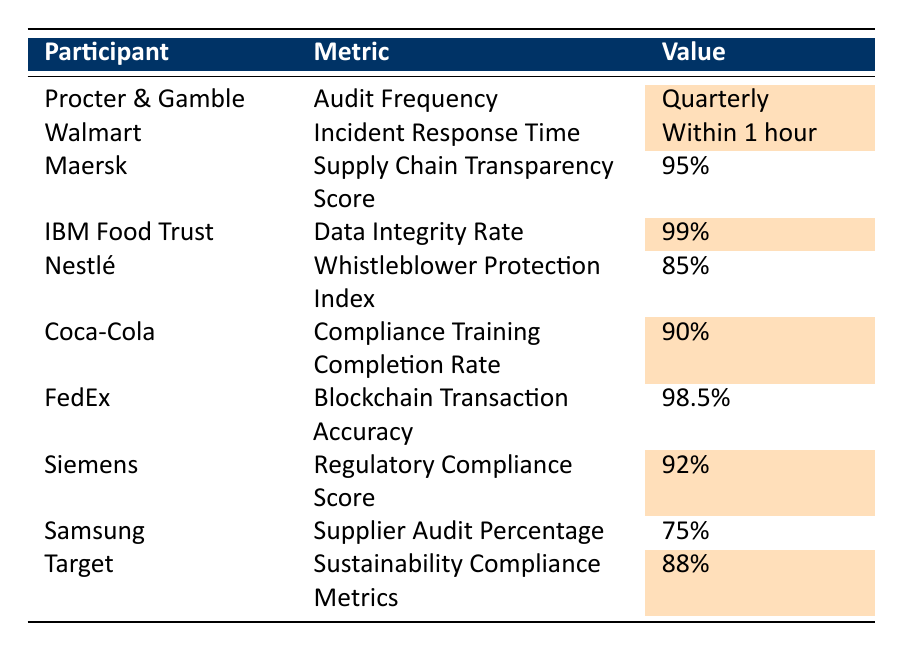What is the audit frequency for Procter & Gamble? According to the table, Procter & Gamble has an audit frequency listed as "Quarterly".
Answer: Quarterly What is the incident response time for Walmart? The table shows that Walmart's incident response time is "Within 1 hour".
Answer: Within 1 hour What percentage of compliance training completion does Coca-Cola have? The value for Coca-Cola's compliance training completion rate is "90%".
Answer: 90% Is the data integrity rate for IBM Food Trust higher than 95%? The data integrity rate for IBM Food Trust is "99%", which is indeed higher than 95%.
Answer: Yes What is the regulatory compliance score for Siemens? Siemens has a regulatory compliance score of "92%", as shown in the table.
Answer: 92% Which participant has the lowest score regarding supply chain transparency? The table does not provide a specific score for supply chain transparency except for Maersk, which is "95%". No participants are listed below this value, so it must be the lowest mentioned.
Answer: Maersk Which participants have highlighted compliance metrics? Looking at the table, the highlighted metrics belong to Procter & Gamble, Walmart, IBM Food Trust, Coca-Cola, Siemens, and Target.
Answer: 6 participants What is the average value of the compliance training completion rate for highlighted participants? The highlighted participants' rates are: Procter & Gamble (Quarterly - not numerical), Walmart (Within 1 hour - not numerical), IBM Food Trust (99%), Coca-Cola (90%), Siemens (92%), Target (88%). Only IBM Food Trust, Coca-Cola, Siemens, and Target have numerical values (99, 90, 92, 88). Adding these values gives 369, and dividing by 4 gives an average of 92.25.
Answer: 92.25 Are there any participants with a compliance metric below 85%? The lowest scores in the table show that Nestlé's Whistleblower Protection Index is "85%", but none fall below it. Therefore, there are no participants with metrics below 85%.
Answer: No Which participant has the highest data integrity rate? The highest data integrity rate listed is for IBM Food Trust at "99%", as shown in the table.
Answer: IBM Food Trust What is the difference between the highest and lowest highlighted compliance metric? The highest highlighted metric is 99% (IBM Food Trust) and the lowest is 88% (Target). The difference is calculated as 99% - 88% = 11%.
Answer: 11% 